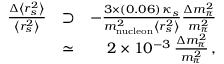Convert formula to latex. <formula><loc_0><loc_0><loc_500><loc_500>\begin{array} { r l r } { \frac { \Delta \left < r _ { s } ^ { 2 } \right > } { \left < r _ { s } ^ { 2 } \right > } } & { \supset } & { - \frac { 3 \times ( 0 . 0 6 ) \, \kappa _ { s } } { m _ { n u c l e o n } ^ { 2 } \left < r _ { s } ^ { 2 } \right > } \frac { \Delta m _ { \pi } ^ { 2 } } { m _ { \pi } ^ { 2 } } } \\ & { \simeq } & { 2 \times 1 0 ^ { - 3 } \, \frac { \Delta m _ { \pi } ^ { 2 } } { m _ { \pi } ^ { 2 } } \, , } \end{array}</formula> 